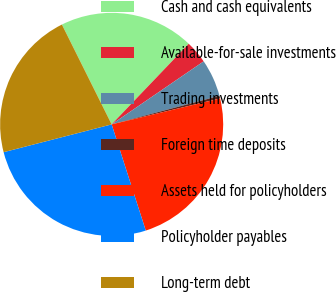Convert chart to OTSL. <chart><loc_0><loc_0><loc_500><loc_500><pie_chart><fcel>Cash and cash equivalents<fcel>Available-for-sale investments<fcel>Trading investments<fcel>Foreign time deposits<fcel>Assets held for policyholders<fcel>Policyholder payables<fcel>Long-term debt<nl><fcel>19.5%<fcel>3.3%<fcel>5.44%<fcel>0.38%<fcel>23.79%<fcel>25.94%<fcel>21.65%<nl></chart> 